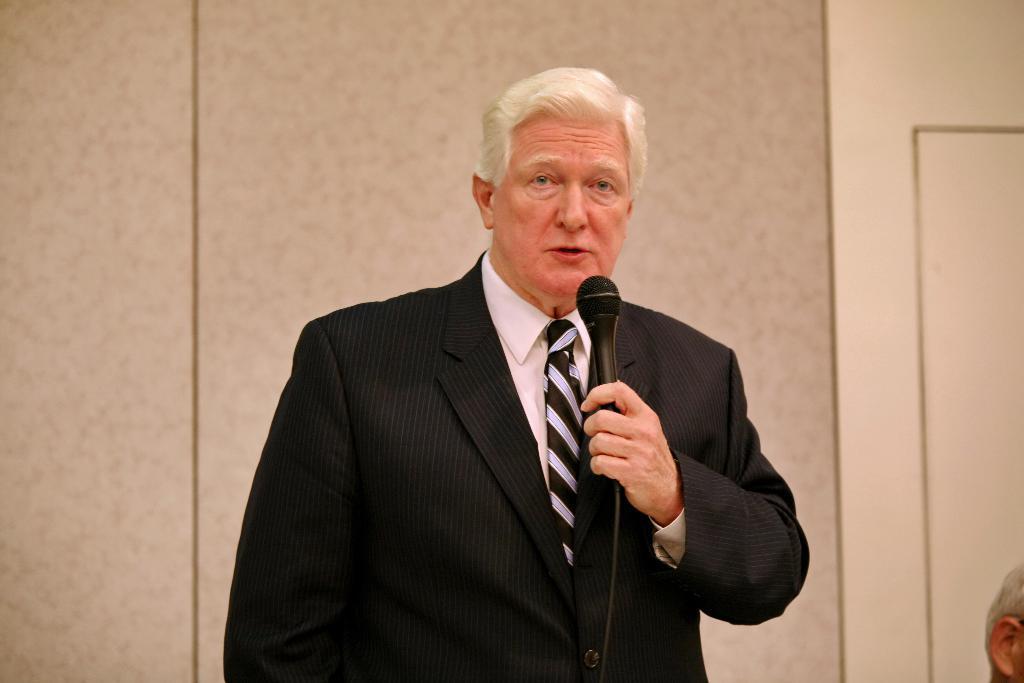Can you describe this image briefly? In this image we can see a man wearing black blazer is holding a mic in his hand and speaking. 